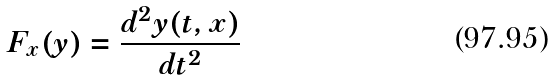Convert formula to latex. <formula><loc_0><loc_0><loc_500><loc_500>F _ { x } ( y ) = \frac { d ^ { 2 } y ( t , x ) } { d t ^ { 2 } }</formula> 